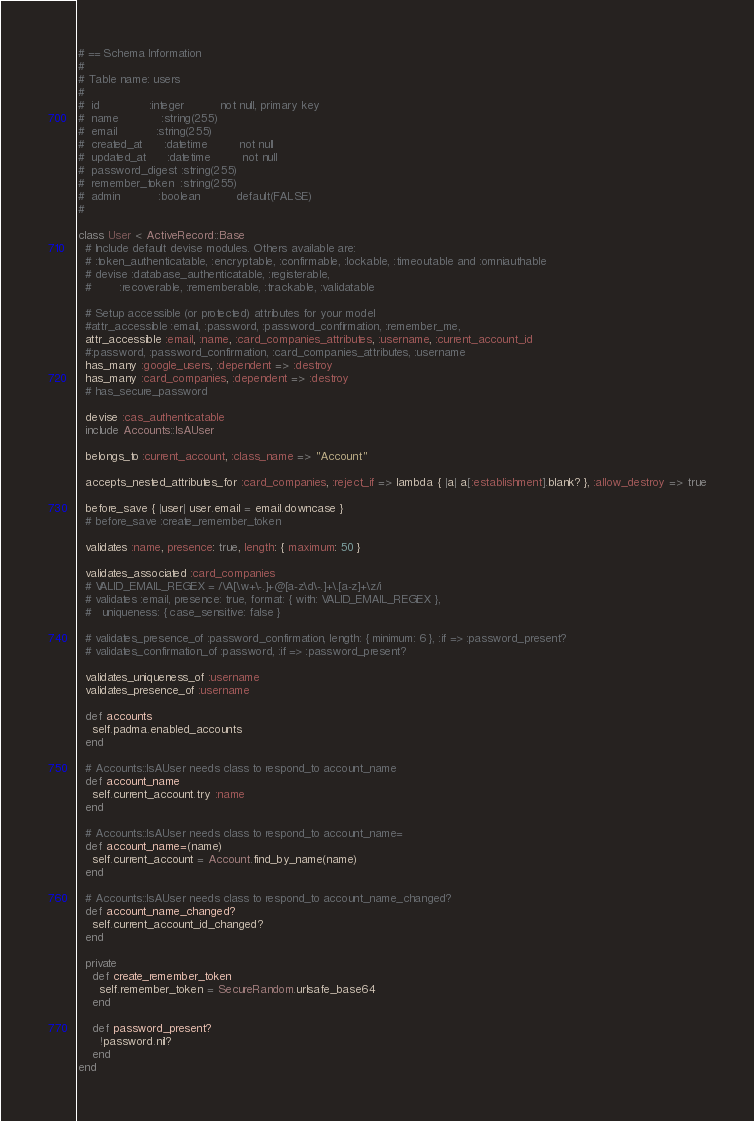Convert code to text. <code><loc_0><loc_0><loc_500><loc_500><_Ruby_># == Schema Information
#
# Table name: users
#
#  id              :integer          not null, primary key
#  name            :string(255)
#  email           :string(255)
#  created_at      :datetime         not null
#  updated_at      :datetime         not null
#  password_digest :string(255)
#  remember_token  :string(255)
#  admin           :boolean          default(FALSE)
#

class User < ActiveRecord::Base
  # Include default devise modules. Others available are:
  # :token_authenticatable, :encryptable, :confirmable, :lockable, :timeoutable and :omniauthable
  # devise :database_authenticatable, :registerable,
  #        :recoverable, :rememberable, :trackable, :validatable

  # Setup accessible (or protected) attributes for your model
  #attr_accessible :email, :password, :password_confirmation, :remember_me,
  attr_accessible :email, :name, :card_companies_attributes, :username, :current_account_id
  #:password, :password_confirmation, :card_companies_attributes, :username
  has_many :google_users, :dependent => :destroy
  has_many :card_companies, :dependent => :destroy
  # has_secure_password

  devise :cas_authenticatable
  include Accounts::IsAUser

  belongs_to :current_account, :class_name => "Account"

  accepts_nested_attributes_for :card_companies, :reject_if => lambda { |a| a[:establishment].blank? }, :allow_destroy => true

  before_save { |user| user.email = email.downcase }
  # before_save :create_remember_token

  validates :name, presence: true, length: { maximum: 50 }

  validates_associated :card_companies
  # VALID_EMAIL_REGEX = /\A[\w+\-.]+@[a-z\d\-.]+\.[a-z]+\z/i
  # validates :email, presence: true, format: { with: VALID_EMAIL_REGEX },
  #   uniqueness: { case_sensitive: false }
    
  # validates_presence_of :password_confirmation, length: { minimum: 6 }, :if => :password_present?
  # validates_confirmation_of :password, :if => :password_present?

  validates_uniqueness_of :username
  validates_presence_of :username

  def accounts
    self.padma.enabled_accounts
  end

  # Accounts::IsAUser needs class to respond_to account_name
  def account_name
    self.current_account.try :name
  end

  # Accounts::IsAUser needs class to respond_to account_name=
  def account_name=(name)
    self.current_account = Account.find_by_name(name)
  end

  # Accounts::IsAUser needs class to respond_to account_name_changed?
  def account_name_changed?
    self.current_account_id_changed?
  end

  private
    def create_remember_token
      self.remember_token = SecureRandom.urlsafe_base64
    end

    def password_present?
      !password.nil?
    end
end
</code> 